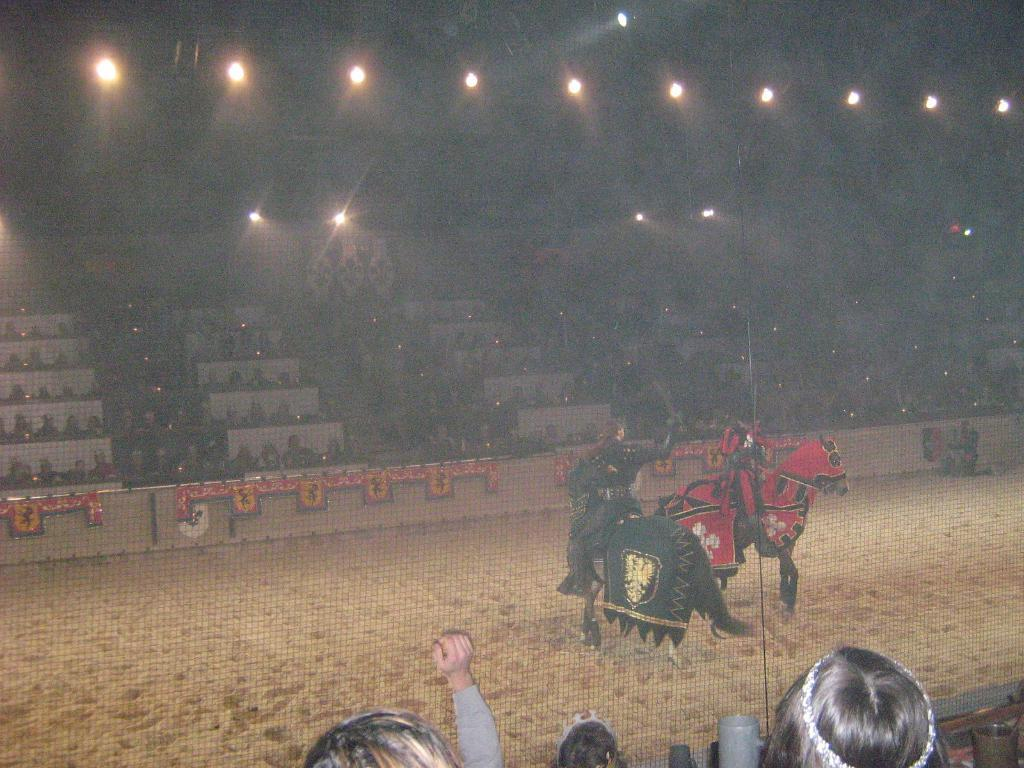How many people are in the image? There are two people in the image. What are the people doing in the image? The people are sitting on horses. Where are the horses located in the image? The horses are on the ground. What can be seen in the background of the image? There is a stadium in the background, and many people are sitting in it. What type of scarf is the horse wearing in the image? There is no scarf present on the horses in the image. Can you see a guitar being played by one of the people in the image? There is no guitar visible in the image; the people are sitting on horses. 